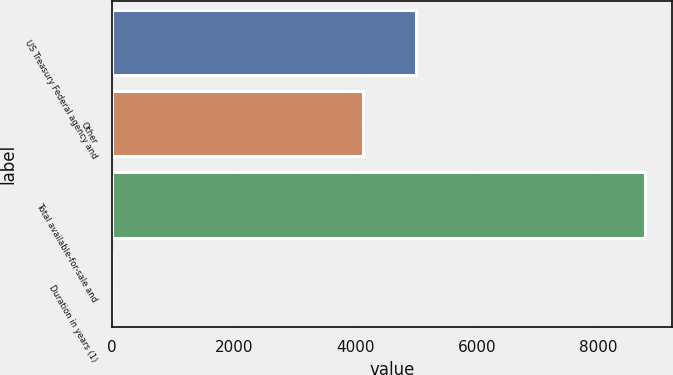Convert chart to OTSL. <chart><loc_0><loc_0><loc_500><loc_500><bar_chart><fcel>US Treasury Federal agency and<fcel>Other<fcel>Total available-for-sale and<fcel>Duration in years (1)<nl><fcel>5008.98<fcel>4132<fcel>8775<fcel>5.2<nl></chart> 